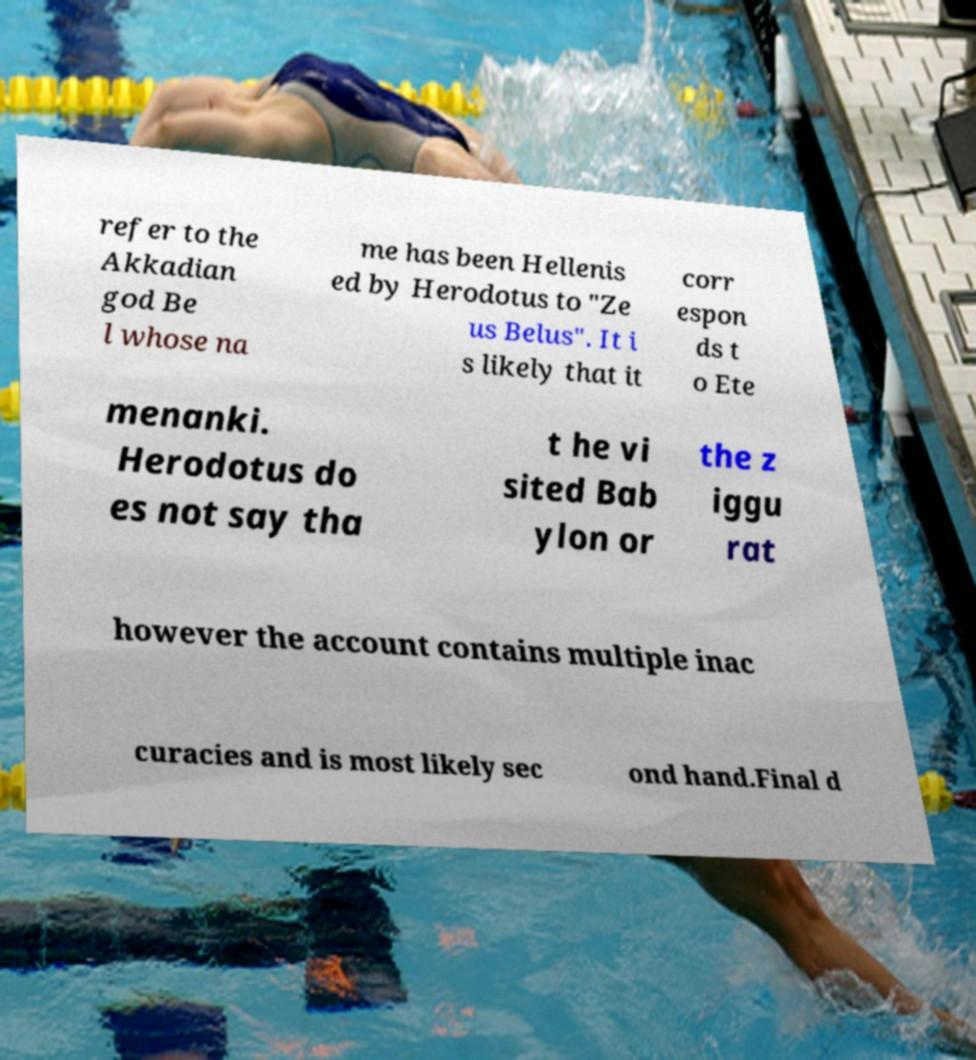Could you extract and type out the text from this image? refer to the Akkadian god Be l whose na me has been Hellenis ed by Herodotus to "Ze us Belus". It i s likely that it corr espon ds t o Ete menanki. Herodotus do es not say tha t he vi sited Bab ylon or the z iggu rat however the account contains multiple inac curacies and is most likely sec ond hand.Final d 